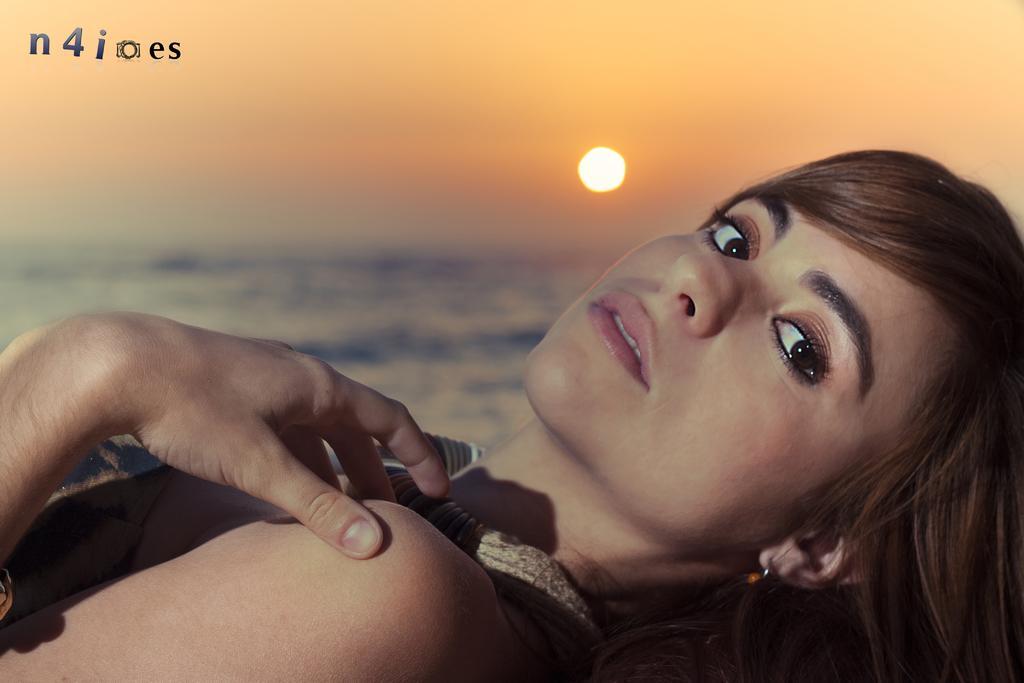In one or two sentences, can you explain what this image depicts? In the foreground of the image there is a lady. In the background of the image there is sky, water and sun. At the top of the image there is some text. 